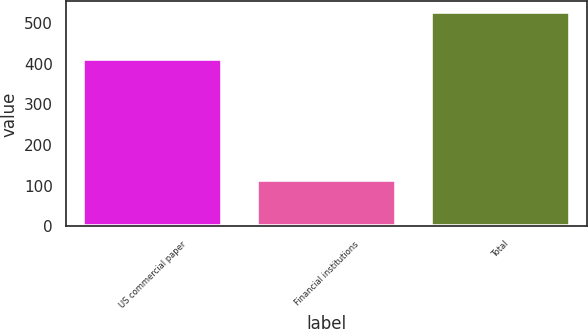<chart> <loc_0><loc_0><loc_500><loc_500><bar_chart><fcel>US commercial paper<fcel>Financial institutions<fcel>Total<nl><fcel>412<fcel>114.5<fcel>526.5<nl></chart> 